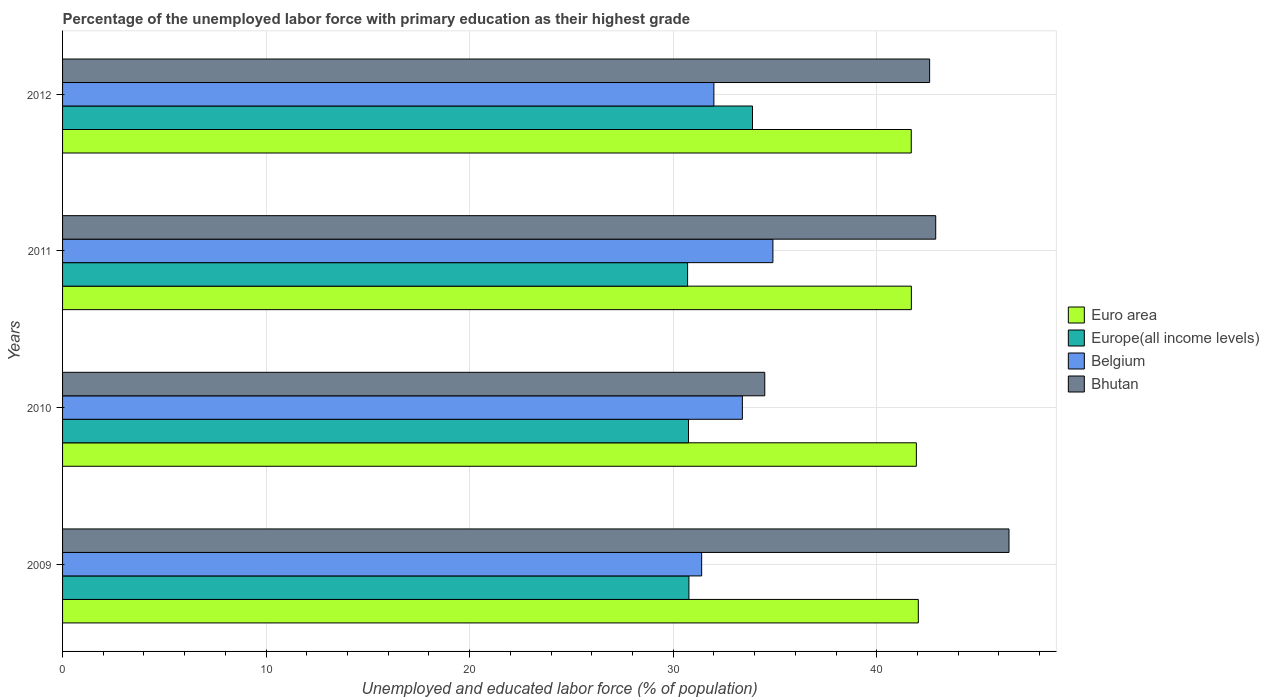How many different coloured bars are there?
Your answer should be very brief. 4. Are the number of bars per tick equal to the number of legend labels?
Give a very brief answer. Yes. How many bars are there on the 3rd tick from the top?
Your response must be concise. 4. How many bars are there on the 3rd tick from the bottom?
Keep it short and to the point. 4. What is the label of the 2nd group of bars from the top?
Your response must be concise. 2011. In how many cases, is the number of bars for a given year not equal to the number of legend labels?
Your answer should be very brief. 0. What is the percentage of the unemployed labor force with primary education in Europe(all income levels) in 2012?
Your answer should be compact. 33.9. Across all years, what is the maximum percentage of the unemployed labor force with primary education in Belgium?
Give a very brief answer. 34.9. Across all years, what is the minimum percentage of the unemployed labor force with primary education in Europe(all income levels)?
Your answer should be compact. 30.71. In which year was the percentage of the unemployed labor force with primary education in Bhutan maximum?
Your response must be concise. 2009. What is the total percentage of the unemployed labor force with primary education in Bhutan in the graph?
Your response must be concise. 166.5. What is the difference between the percentage of the unemployed labor force with primary education in Euro area in 2010 and that in 2011?
Make the answer very short. 0.25. What is the difference between the percentage of the unemployed labor force with primary education in Bhutan in 2009 and the percentage of the unemployed labor force with primary education in Belgium in 2011?
Ensure brevity in your answer.  11.6. What is the average percentage of the unemployed labor force with primary education in Belgium per year?
Make the answer very short. 32.93. In the year 2009, what is the difference between the percentage of the unemployed labor force with primary education in Bhutan and percentage of the unemployed labor force with primary education in Europe(all income levels)?
Give a very brief answer. 15.73. In how many years, is the percentage of the unemployed labor force with primary education in Bhutan greater than 12 %?
Provide a short and direct response. 4. What is the ratio of the percentage of the unemployed labor force with primary education in Europe(all income levels) in 2009 to that in 2012?
Your answer should be compact. 0.91. Is the percentage of the unemployed labor force with primary education in Bhutan in 2009 less than that in 2011?
Your answer should be compact. No. Is the difference between the percentage of the unemployed labor force with primary education in Bhutan in 2011 and 2012 greater than the difference between the percentage of the unemployed labor force with primary education in Europe(all income levels) in 2011 and 2012?
Offer a very short reply. Yes. In how many years, is the percentage of the unemployed labor force with primary education in Europe(all income levels) greater than the average percentage of the unemployed labor force with primary education in Europe(all income levels) taken over all years?
Offer a terse response. 1. Is the sum of the percentage of the unemployed labor force with primary education in Bhutan in 2009 and 2011 greater than the maximum percentage of the unemployed labor force with primary education in Belgium across all years?
Your answer should be very brief. Yes. What does the 1st bar from the top in 2010 represents?
Make the answer very short. Bhutan. What does the 1st bar from the bottom in 2011 represents?
Your response must be concise. Euro area. What is the difference between two consecutive major ticks on the X-axis?
Keep it short and to the point. 10. Does the graph contain any zero values?
Keep it short and to the point. No. How many legend labels are there?
Offer a terse response. 4. What is the title of the graph?
Offer a terse response. Percentage of the unemployed labor force with primary education as their highest grade. What is the label or title of the X-axis?
Your answer should be very brief. Unemployed and educated labor force (% of population). What is the label or title of the Y-axis?
Provide a succinct answer. Years. What is the Unemployed and educated labor force (% of population) in Euro area in 2009?
Your answer should be very brief. 42.04. What is the Unemployed and educated labor force (% of population) in Europe(all income levels) in 2009?
Ensure brevity in your answer.  30.77. What is the Unemployed and educated labor force (% of population) in Belgium in 2009?
Offer a very short reply. 31.4. What is the Unemployed and educated labor force (% of population) in Bhutan in 2009?
Provide a succinct answer. 46.5. What is the Unemployed and educated labor force (% of population) of Euro area in 2010?
Your response must be concise. 41.95. What is the Unemployed and educated labor force (% of population) in Europe(all income levels) in 2010?
Provide a succinct answer. 30.75. What is the Unemployed and educated labor force (% of population) of Belgium in 2010?
Keep it short and to the point. 33.4. What is the Unemployed and educated labor force (% of population) in Bhutan in 2010?
Make the answer very short. 34.5. What is the Unemployed and educated labor force (% of population) in Euro area in 2011?
Your response must be concise. 41.7. What is the Unemployed and educated labor force (% of population) of Europe(all income levels) in 2011?
Ensure brevity in your answer.  30.71. What is the Unemployed and educated labor force (% of population) of Belgium in 2011?
Keep it short and to the point. 34.9. What is the Unemployed and educated labor force (% of population) in Bhutan in 2011?
Your answer should be compact. 42.9. What is the Unemployed and educated labor force (% of population) in Euro area in 2012?
Provide a succinct answer. 41.7. What is the Unemployed and educated labor force (% of population) in Europe(all income levels) in 2012?
Provide a short and direct response. 33.9. What is the Unemployed and educated labor force (% of population) of Belgium in 2012?
Your answer should be very brief. 32. What is the Unemployed and educated labor force (% of population) of Bhutan in 2012?
Give a very brief answer. 42.6. Across all years, what is the maximum Unemployed and educated labor force (% of population) of Euro area?
Your response must be concise. 42.04. Across all years, what is the maximum Unemployed and educated labor force (% of population) of Europe(all income levels)?
Provide a short and direct response. 33.9. Across all years, what is the maximum Unemployed and educated labor force (% of population) of Belgium?
Offer a terse response. 34.9. Across all years, what is the maximum Unemployed and educated labor force (% of population) in Bhutan?
Provide a short and direct response. 46.5. Across all years, what is the minimum Unemployed and educated labor force (% of population) in Euro area?
Offer a terse response. 41.7. Across all years, what is the minimum Unemployed and educated labor force (% of population) of Europe(all income levels)?
Provide a short and direct response. 30.71. Across all years, what is the minimum Unemployed and educated labor force (% of population) in Belgium?
Give a very brief answer. 31.4. Across all years, what is the minimum Unemployed and educated labor force (% of population) of Bhutan?
Ensure brevity in your answer.  34.5. What is the total Unemployed and educated labor force (% of population) of Euro area in the graph?
Provide a succinct answer. 167.39. What is the total Unemployed and educated labor force (% of population) of Europe(all income levels) in the graph?
Offer a terse response. 126.13. What is the total Unemployed and educated labor force (% of population) in Belgium in the graph?
Provide a succinct answer. 131.7. What is the total Unemployed and educated labor force (% of population) of Bhutan in the graph?
Ensure brevity in your answer.  166.5. What is the difference between the Unemployed and educated labor force (% of population) in Euro area in 2009 and that in 2010?
Provide a short and direct response. 0.1. What is the difference between the Unemployed and educated labor force (% of population) in Europe(all income levels) in 2009 and that in 2010?
Provide a short and direct response. 0.02. What is the difference between the Unemployed and educated labor force (% of population) in Belgium in 2009 and that in 2010?
Offer a terse response. -2. What is the difference between the Unemployed and educated labor force (% of population) in Bhutan in 2009 and that in 2010?
Your answer should be very brief. 12. What is the difference between the Unemployed and educated labor force (% of population) in Euro area in 2009 and that in 2011?
Offer a very short reply. 0.34. What is the difference between the Unemployed and educated labor force (% of population) in Europe(all income levels) in 2009 and that in 2011?
Your response must be concise. 0.07. What is the difference between the Unemployed and educated labor force (% of population) in Belgium in 2009 and that in 2011?
Your answer should be very brief. -3.5. What is the difference between the Unemployed and educated labor force (% of population) in Euro area in 2009 and that in 2012?
Your answer should be compact. 0.35. What is the difference between the Unemployed and educated labor force (% of population) in Europe(all income levels) in 2009 and that in 2012?
Ensure brevity in your answer.  -3.12. What is the difference between the Unemployed and educated labor force (% of population) in Euro area in 2010 and that in 2011?
Offer a very short reply. 0.25. What is the difference between the Unemployed and educated labor force (% of population) in Europe(all income levels) in 2010 and that in 2011?
Your response must be concise. 0.04. What is the difference between the Unemployed and educated labor force (% of population) in Belgium in 2010 and that in 2011?
Provide a succinct answer. -1.5. What is the difference between the Unemployed and educated labor force (% of population) in Euro area in 2010 and that in 2012?
Provide a short and direct response. 0.25. What is the difference between the Unemployed and educated labor force (% of population) of Europe(all income levels) in 2010 and that in 2012?
Provide a short and direct response. -3.15. What is the difference between the Unemployed and educated labor force (% of population) in Euro area in 2011 and that in 2012?
Keep it short and to the point. 0. What is the difference between the Unemployed and educated labor force (% of population) in Europe(all income levels) in 2011 and that in 2012?
Provide a short and direct response. -3.19. What is the difference between the Unemployed and educated labor force (% of population) of Belgium in 2011 and that in 2012?
Ensure brevity in your answer.  2.9. What is the difference between the Unemployed and educated labor force (% of population) of Bhutan in 2011 and that in 2012?
Offer a terse response. 0.3. What is the difference between the Unemployed and educated labor force (% of population) in Euro area in 2009 and the Unemployed and educated labor force (% of population) in Europe(all income levels) in 2010?
Make the answer very short. 11.29. What is the difference between the Unemployed and educated labor force (% of population) in Euro area in 2009 and the Unemployed and educated labor force (% of population) in Belgium in 2010?
Provide a succinct answer. 8.64. What is the difference between the Unemployed and educated labor force (% of population) in Euro area in 2009 and the Unemployed and educated labor force (% of population) in Bhutan in 2010?
Offer a terse response. 7.54. What is the difference between the Unemployed and educated labor force (% of population) in Europe(all income levels) in 2009 and the Unemployed and educated labor force (% of population) in Belgium in 2010?
Ensure brevity in your answer.  -2.63. What is the difference between the Unemployed and educated labor force (% of population) of Europe(all income levels) in 2009 and the Unemployed and educated labor force (% of population) of Bhutan in 2010?
Provide a short and direct response. -3.73. What is the difference between the Unemployed and educated labor force (% of population) of Euro area in 2009 and the Unemployed and educated labor force (% of population) of Europe(all income levels) in 2011?
Offer a very short reply. 11.34. What is the difference between the Unemployed and educated labor force (% of population) in Euro area in 2009 and the Unemployed and educated labor force (% of population) in Belgium in 2011?
Make the answer very short. 7.14. What is the difference between the Unemployed and educated labor force (% of population) in Euro area in 2009 and the Unemployed and educated labor force (% of population) in Bhutan in 2011?
Make the answer very short. -0.86. What is the difference between the Unemployed and educated labor force (% of population) in Europe(all income levels) in 2009 and the Unemployed and educated labor force (% of population) in Belgium in 2011?
Keep it short and to the point. -4.13. What is the difference between the Unemployed and educated labor force (% of population) of Europe(all income levels) in 2009 and the Unemployed and educated labor force (% of population) of Bhutan in 2011?
Provide a short and direct response. -12.13. What is the difference between the Unemployed and educated labor force (% of population) in Euro area in 2009 and the Unemployed and educated labor force (% of population) in Europe(all income levels) in 2012?
Your answer should be very brief. 8.15. What is the difference between the Unemployed and educated labor force (% of population) of Euro area in 2009 and the Unemployed and educated labor force (% of population) of Belgium in 2012?
Provide a short and direct response. 10.04. What is the difference between the Unemployed and educated labor force (% of population) of Euro area in 2009 and the Unemployed and educated labor force (% of population) of Bhutan in 2012?
Your response must be concise. -0.56. What is the difference between the Unemployed and educated labor force (% of population) in Europe(all income levels) in 2009 and the Unemployed and educated labor force (% of population) in Belgium in 2012?
Offer a terse response. -1.23. What is the difference between the Unemployed and educated labor force (% of population) of Europe(all income levels) in 2009 and the Unemployed and educated labor force (% of population) of Bhutan in 2012?
Make the answer very short. -11.83. What is the difference between the Unemployed and educated labor force (% of population) of Euro area in 2010 and the Unemployed and educated labor force (% of population) of Europe(all income levels) in 2011?
Make the answer very short. 11.24. What is the difference between the Unemployed and educated labor force (% of population) of Euro area in 2010 and the Unemployed and educated labor force (% of population) of Belgium in 2011?
Ensure brevity in your answer.  7.05. What is the difference between the Unemployed and educated labor force (% of population) in Euro area in 2010 and the Unemployed and educated labor force (% of population) in Bhutan in 2011?
Provide a succinct answer. -0.95. What is the difference between the Unemployed and educated labor force (% of population) of Europe(all income levels) in 2010 and the Unemployed and educated labor force (% of population) of Belgium in 2011?
Your response must be concise. -4.15. What is the difference between the Unemployed and educated labor force (% of population) of Europe(all income levels) in 2010 and the Unemployed and educated labor force (% of population) of Bhutan in 2011?
Ensure brevity in your answer.  -12.15. What is the difference between the Unemployed and educated labor force (% of population) of Belgium in 2010 and the Unemployed and educated labor force (% of population) of Bhutan in 2011?
Make the answer very short. -9.5. What is the difference between the Unemployed and educated labor force (% of population) in Euro area in 2010 and the Unemployed and educated labor force (% of population) in Europe(all income levels) in 2012?
Your answer should be compact. 8.05. What is the difference between the Unemployed and educated labor force (% of population) of Euro area in 2010 and the Unemployed and educated labor force (% of population) of Belgium in 2012?
Your answer should be very brief. 9.95. What is the difference between the Unemployed and educated labor force (% of population) of Euro area in 2010 and the Unemployed and educated labor force (% of population) of Bhutan in 2012?
Your answer should be compact. -0.65. What is the difference between the Unemployed and educated labor force (% of population) in Europe(all income levels) in 2010 and the Unemployed and educated labor force (% of population) in Belgium in 2012?
Offer a terse response. -1.25. What is the difference between the Unemployed and educated labor force (% of population) of Europe(all income levels) in 2010 and the Unemployed and educated labor force (% of population) of Bhutan in 2012?
Your answer should be compact. -11.85. What is the difference between the Unemployed and educated labor force (% of population) of Euro area in 2011 and the Unemployed and educated labor force (% of population) of Europe(all income levels) in 2012?
Your answer should be compact. 7.8. What is the difference between the Unemployed and educated labor force (% of population) of Euro area in 2011 and the Unemployed and educated labor force (% of population) of Belgium in 2012?
Your response must be concise. 9.7. What is the difference between the Unemployed and educated labor force (% of population) in Euro area in 2011 and the Unemployed and educated labor force (% of population) in Bhutan in 2012?
Your answer should be very brief. -0.9. What is the difference between the Unemployed and educated labor force (% of population) in Europe(all income levels) in 2011 and the Unemployed and educated labor force (% of population) in Belgium in 2012?
Make the answer very short. -1.29. What is the difference between the Unemployed and educated labor force (% of population) of Europe(all income levels) in 2011 and the Unemployed and educated labor force (% of population) of Bhutan in 2012?
Give a very brief answer. -11.89. What is the average Unemployed and educated labor force (% of population) in Euro area per year?
Keep it short and to the point. 41.85. What is the average Unemployed and educated labor force (% of population) in Europe(all income levels) per year?
Provide a succinct answer. 31.53. What is the average Unemployed and educated labor force (% of population) of Belgium per year?
Offer a terse response. 32.92. What is the average Unemployed and educated labor force (% of population) in Bhutan per year?
Ensure brevity in your answer.  41.62. In the year 2009, what is the difference between the Unemployed and educated labor force (% of population) in Euro area and Unemployed and educated labor force (% of population) in Europe(all income levels)?
Offer a terse response. 11.27. In the year 2009, what is the difference between the Unemployed and educated labor force (% of population) in Euro area and Unemployed and educated labor force (% of population) in Belgium?
Make the answer very short. 10.64. In the year 2009, what is the difference between the Unemployed and educated labor force (% of population) of Euro area and Unemployed and educated labor force (% of population) of Bhutan?
Your response must be concise. -4.46. In the year 2009, what is the difference between the Unemployed and educated labor force (% of population) of Europe(all income levels) and Unemployed and educated labor force (% of population) of Belgium?
Provide a short and direct response. -0.63. In the year 2009, what is the difference between the Unemployed and educated labor force (% of population) of Europe(all income levels) and Unemployed and educated labor force (% of population) of Bhutan?
Ensure brevity in your answer.  -15.73. In the year 2009, what is the difference between the Unemployed and educated labor force (% of population) in Belgium and Unemployed and educated labor force (% of population) in Bhutan?
Your answer should be very brief. -15.1. In the year 2010, what is the difference between the Unemployed and educated labor force (% of population) in Euro area and Unemployed and educated labor force (% of population) in Europe(all income levels)?
Provide a succinct answer. 11.2. In the year 2010, what is the difference between the Unemployed and educated labor force (% of population) in Euro area and Unemployed and educated labor force (% of population) in Belgium?
Offer a very short reply. 8.55. In the year 2010, what is the difference between the Unemployed and educated labor force (% of population) of Euro area and Unemployed and educated labor force (% of population) of Bhutan?
Your response must be concise. 7.45. In the year 2010, what is the difference between the Unemployed and educated labor force (% of population) of Europe(all income levels) and Unemployed and educated labor force (% of population) of Belgium?
Keep it short and to the point. -2.65. In the year 2010, what is the difference between the Unemployed and educated labor force (% of population) in Europe(all income levels) and Unemployed and educated labor force (% of population) in Bhutan?
Offer a very short reply. -3.75. In the year 2010, what is the difference between the Unemployed and educated labor force (% of population) in Belgium and Unemployed and educated labor force (% of population) in Bhutan?
Your response must be concise. -1.1. In the year 2011, what is the difference between the Unemployed and educated labor force (% of population) in Euro area and Unemployed and educated labor force (% of population) in Europe(all income levels)?
Make the answer very short. 10.99. In the year 2011, what is the difference between the Unemployed and educated labor force (% of population) in Euro area and Unemployed and educated labor force (% of population) in Belgium?
Your answer should be compact. 6.8. In the year 2011, what is the difference between the Unemployed and educated labor force (% of population) in Euro area and Unemployed and educated labor force (% of population) in Bhutan?
Offer a very short reply. -1.2. In the year 2011, what is the difference between the Unemployed and educated labor force (% of population) of Europe(all income levels) and Unemployed and educated labor force (% of population) of Belgium?
Your response must be concise. -4.19. In the year 2011, what is the difference between the Unemployed and educated labor force (% of population) in Europe(all income levels) and Unemployed and educated labor force (% of population) in Bhutan?
Keep it short and to the point. -12.19. In the year 2012, what is the difference between the Unemployed and educated labor force (% of population) of Euro area and Unemployed and educated labor force (% of population) of Europe(all income levels)?
Provide a short and direct response. 7.8. In the year 2012, what is the difference between the Unemployed and educated labor force (% of population) of Euro area and Unemployed and educated labor force (% of population) of Belgium?
Ensure brevity in your answer.  9.7. In the year 2012, what is the difference between the Unemployed and educated labor force (% of population) in Euro area and Unemployed and educated labor force (% of population) in Bhutan?
Provide a succinct answer. -0.9. In the year 2012, what is the difference between the Unemployed and educated labor force (% of population) of Europe(all income levels) and Unemployed and educated labor force (% of population) of Belgium?
Your response must be concise. 1.9. In the year 2012, what is the difference between the Unemployed and educated labor force (% of population) of Europe(all income levels) and Unemployed and educated labor force (% of population) of Bhutan?
Your answer should be very brief. -8.7. In the year 2012, what is the difference between the Unemployed and educated labor force (% of population) of Belgium and Unemployed and educated labor force (% of population) of Bhutan?
Provide a succinct answer. -10.6. What is the ratio of the Unemployed and educated labor force (% of population) of Euro area in 2009 to that in 2010?
Provide a succinct answer. 1. What is the ratio of the Unemployed and educated labor force (% of population) of Belgium in 2009 to that in 2010?
Provide a short and direct response. 0.94. What is the ratio of the Unemployed and educated labor force (% of population) in Bhutan in 2009 to that in 2010?
Your response must be concise. 1.35. What is the ratio of the Unemployed and educated labor force (% of population) in Euro area in 2009 to that in 2011?
Make the answer very short. 1.01. What is the ratio of the Unemployed and educated labor force (% of population) in Europe(all income levels) in 2009 to that in 2011?
Provide a succinct answer. 1. What is the ratio of the Unemployed and educated labor force (% of population) of Belgium in 2009 to that in 2011?
Ensure brevity in your answer.  0.9. What is the ratio of the Unemployed and educated labor force (% of population) of Bhutan in 2009 to that in 2011?
Provide a succinct answer. 1.08. What is the ratio of the Unemployed and educated labor force (% of population) of Euro area in 2009 to that in 2012?
Make the answer very short. 1.01. What is the ratio of the Unemployed and educated labor force (% of population) of Europe(all income levels) in 2009 to that in 2012?
Provide a short and direct response. 0.91. What is the ratio of the Unemployed and educated labor force (% of population) in Belgium in 2009 to that in 2012?
Keep it short and to the point. 0.98. What is the ratio of the Unemployed and educated labor force (% of population) of Bhutan in 2009 to that in 2012?
Keep it short and to the point. 1.09. What is the ratio of the Unemployed and educated labor force (% of population) of Euro area in 2010 to that in 2011?
Your answer should be very brief. 1.01. What is the ratio of the Unemployed and educated labor force (% of population) in Belgium in 2010 to that in 2011?
Ensure brevity in your answer.  0.96. What is the ratio of the Unemployed and educated labor force (% of population) of Bhutan in 2010 to that in 2011?
Provide a short and direct response. 0.8. What is the ratio of the Unemployed and educated labor force (% of population) of Europe(all income levels) in 2010 to that in 2012?
Provide a succinct answer. 0.91. What is the ratio of the Unemployed and educated labor force (% of population) in Belgium in 2010 to that in 2012?
Make the answer very short. 1.04. What is the ratio of the Unemployed and educated labor force (% of population) of Bhutan in 2010 to that in 2012?
Your response must be concise. 0.81. What is the ratio of the Unemployed and educated labor force (% of population) in Euro area in 2011 to that in 2012?
Your answer should be very brief. 1. What is the ratio of the Unemployed and educated labor force (% of population) in Europe(all income levels) in 2011 to that in 2012?
Offer a terse response. 0.91. What is the ratio of the Unemployed and educated labor force (% of population) in Belgium in 2011 to that in 2012?
Ensure brevity in your answer.  1.09. What is the ratio of the Unemployed and educated labor force (% of population) of Bhutan in 2011 to that in 2012?
Ensure brevity in your answer.  1.01. What is the difference between the highest and the second highest Unemployed and educated labor force (% of population) of Euro area?
Offer a very short reply. 0.1. What is the difference between the highest and the second highest Unemployed and educated labor force (% of population) of Europe(all income levels)?
Give a very brief answer. 3.12. What is the difference between the highest and the second highest Unemployed and educated labor force (% of population) of Belgium?
Your response must be concise. 1.5. What is the difference between the highest and the second highest Unemployed and educated labor force (% of population) of Bhutan?
Provide a succinct answer. 3.6. What is the difference between the highest and the lowest Unemployed and educated labor force (% of population) of Euro area?
Your answer should be compact. 0.35. What is the difference between the highest and the lowest Unemployed and educated labor force (% of population) in Europe(all income levels)?
Make the answer very short. 3.19. What is the difference between the highest and the lowest Unemployed and educated labor force (% of population) of Belgium?
Your response must be concise. 3.5. What is the difference between the highest and the lowest Unemployed and educated labor force (% of population) of Bhutan?
Offer a very short reply. 12. 